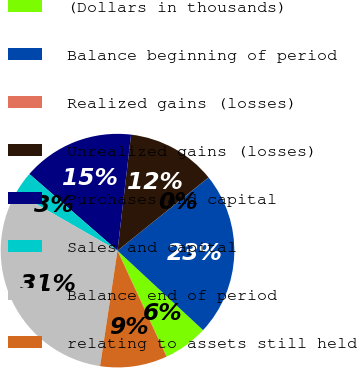Convert chart to OTSL. <chart><loc_0><loc_0><loc_500><loc_500><pie_chart><fcel>(Dollars in thousands)<fcel>Balance beginning of period<fcel>Realized gains (losses)<fcel>Unrealized gains (losses)<fcel>Purchases and capital<fcel>Sales and capital<fcel>Balance end of period<fcel>relating to assets still held<nl><fcel>6.19%<fcel>22.68%<fcel>0.01%<fcel>12.37%<fcel>15.46%<fcel>3.1%<fcel>30.91%<fcel>9.28%<nl></chart> 